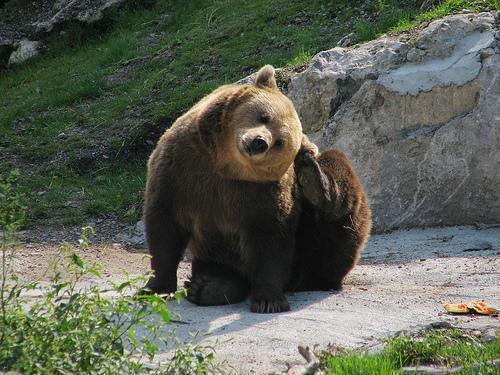How many bears?
Give a very brief answer. 1. 